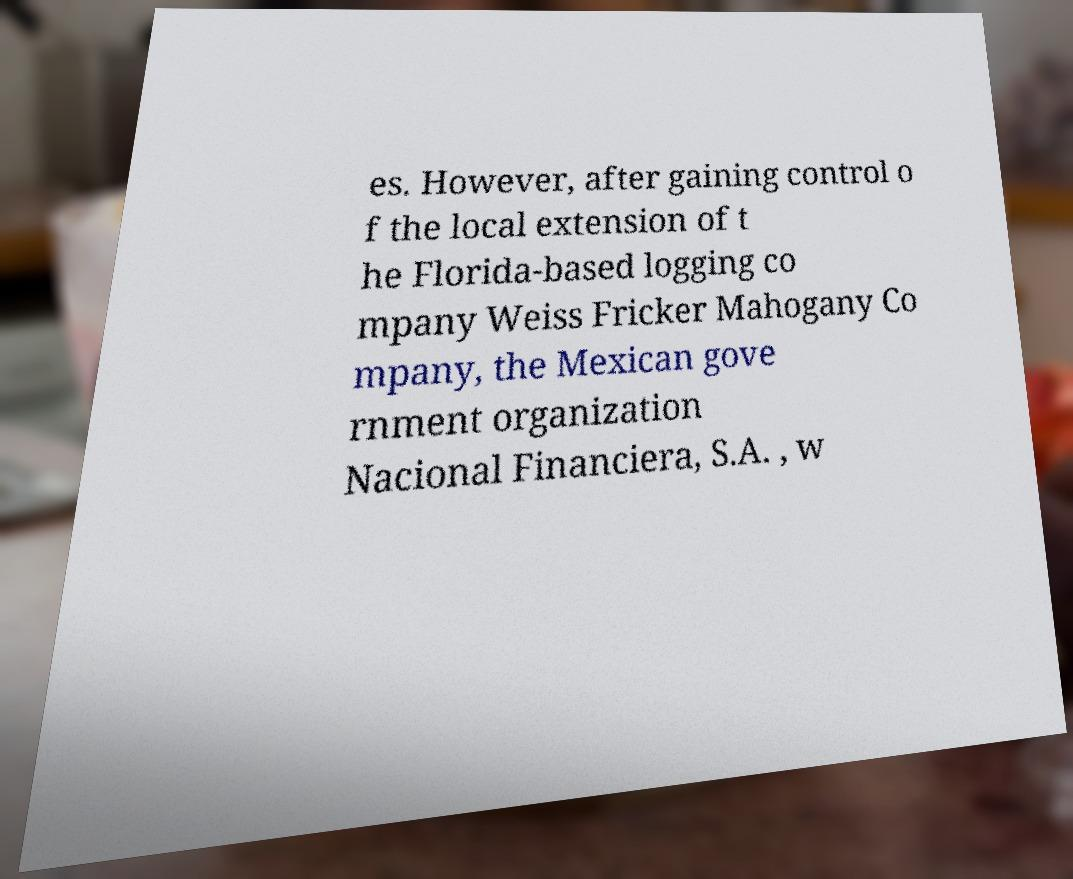Can you accurately transcribe the text from the provided image for me? es. However, after gaining control o f the local extension of t he Florida-based logging co mpany Weiss Fricker Mahogany Co mpany, the Mexican gove rnment organization Nacional Financiera, S.A. , w 